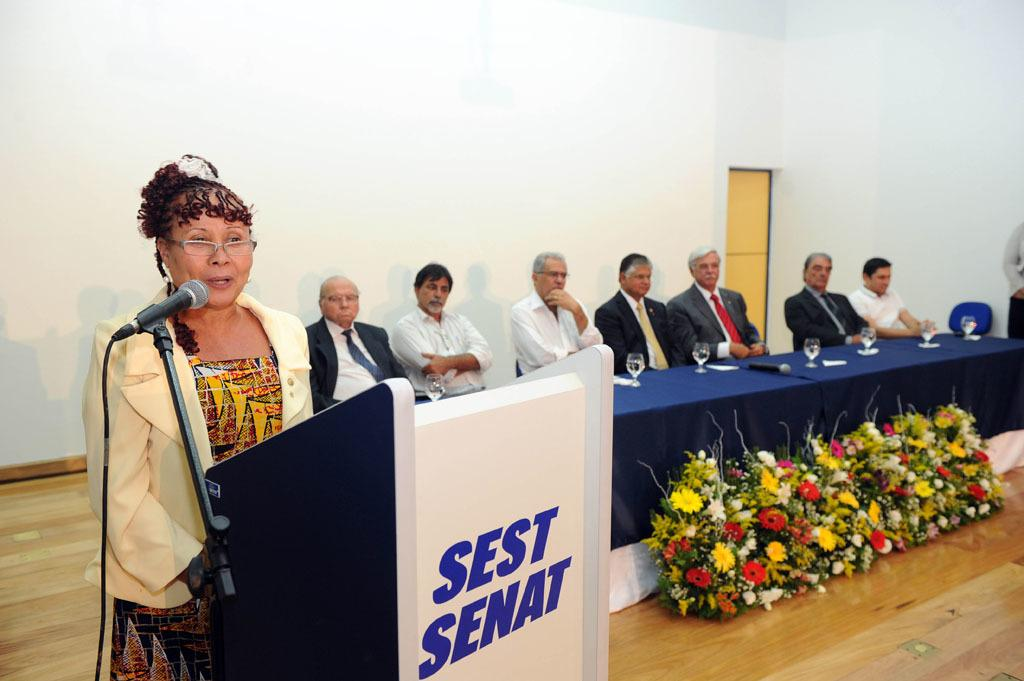<image>
Share a concise interpretation of the image provided. A woman presenting at a meeting, the podium says Sest Senat. 